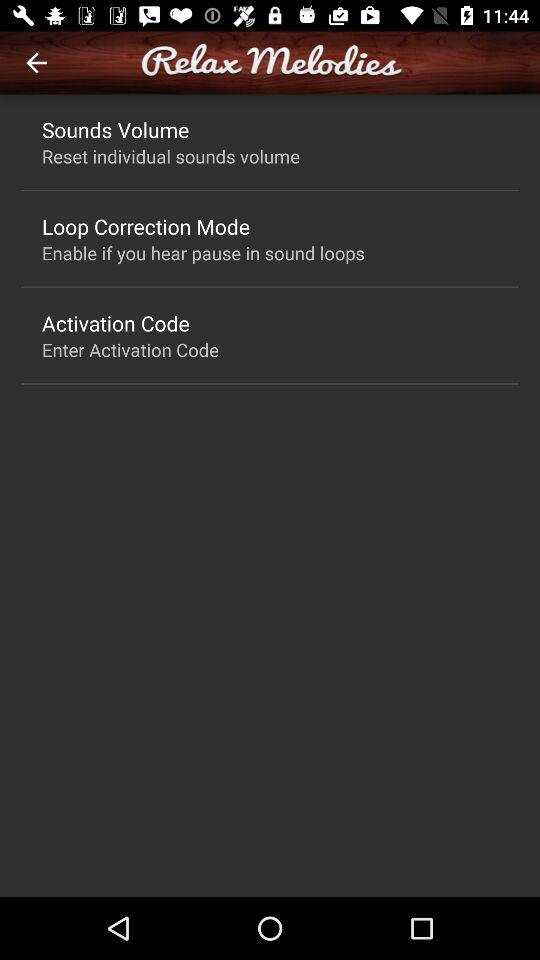What is the setting for the loop correction mode? The setting for the loop correction mode is "Enable if you hear pause in sound loops". 